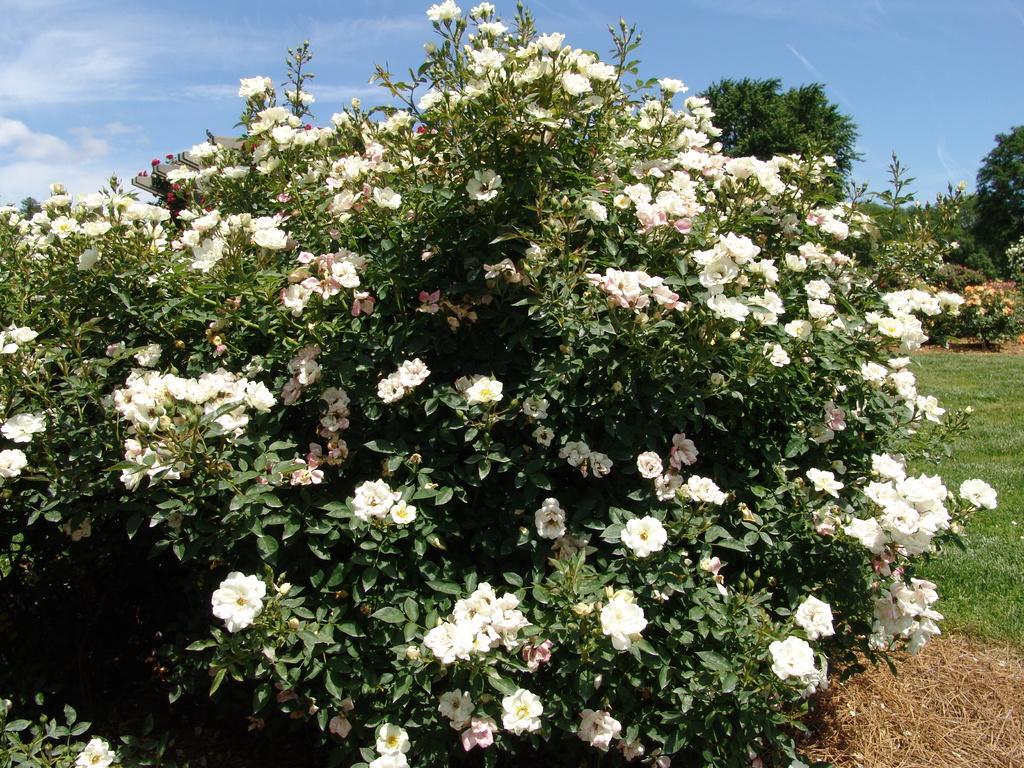Could you give a brief overview of what you see in this image? In the foreground I can see flowering plants, grass and trees. On the top I can see the sky. This image is taken in a garden. 